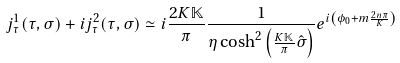Convert formula to latex. <formula><loc_0><loc_0><loc_500><loc_500>j ^ { 1 } _ { \tau } ( \tau , \sigma ) + i j ^ { 2 } _ { \tau } ( \tau , \sigma ) \simeq i \frac { 2 K \mathbb { K } } { \pi } \frac { 1 } { \eta \cosh ^ { 2 } \left ( \frac { K \mathbb { K } } { \pi } \hat { \sigma } \right ) } e ^ { i \left ( \phi _ { 0 } + m \frac { 2 n \pi } { K } \right ) }</formula> 